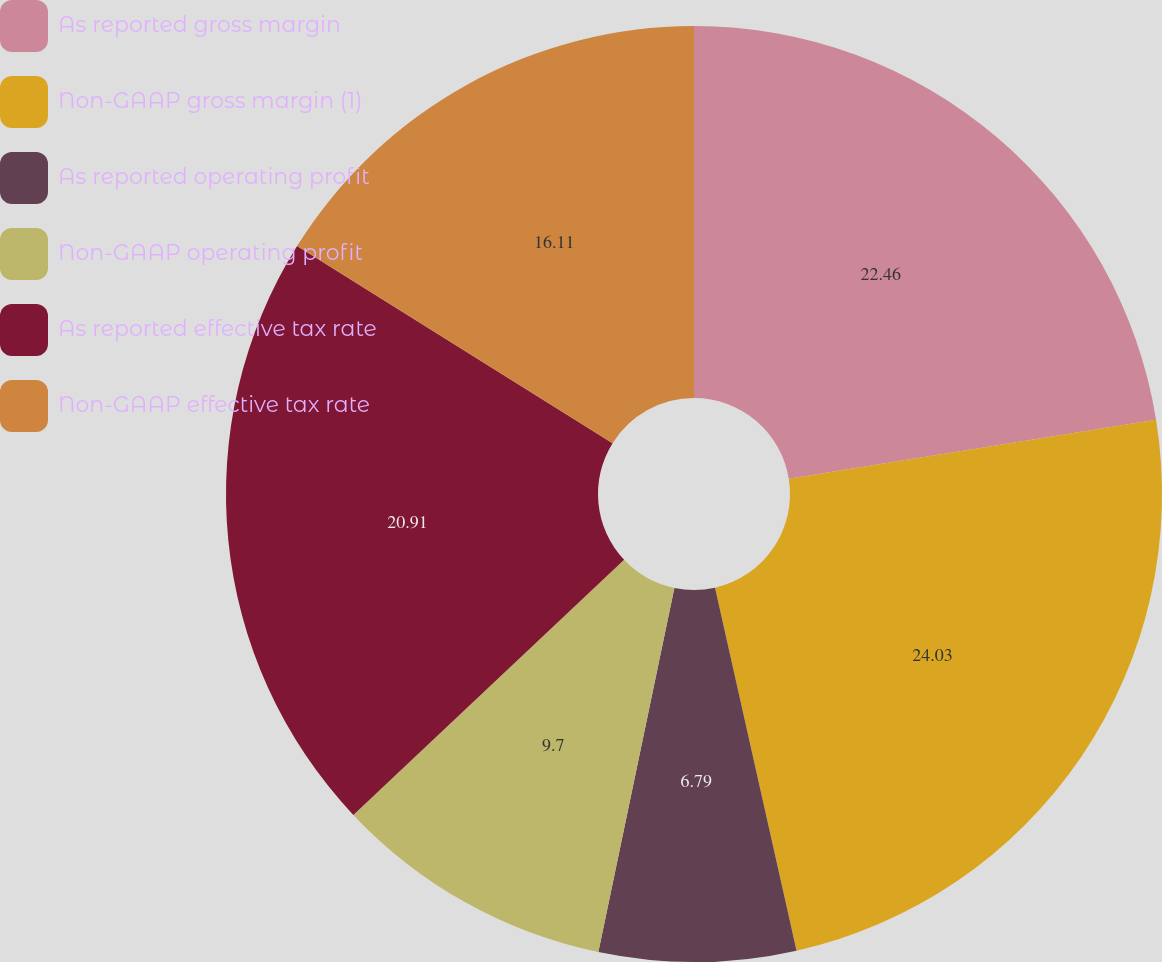Convert chart. <chart><loc_0><loc_0><loc_500><loc_500><pie_chart><fcel>As reported gross margin<fcel>Non-GAAP gross margin (1)<fcel>As reported operating profit<fcel>Non-GAAP operating profit<fcel>As reported effective tax rate<fcel>Non-GAAP effective tax rate<nl><fcel>22.46%<fcel>24.02%<fcel>6.79%<fcel>9.7%<fcel>20.91%<fcel>16.11%<nl></chart> 